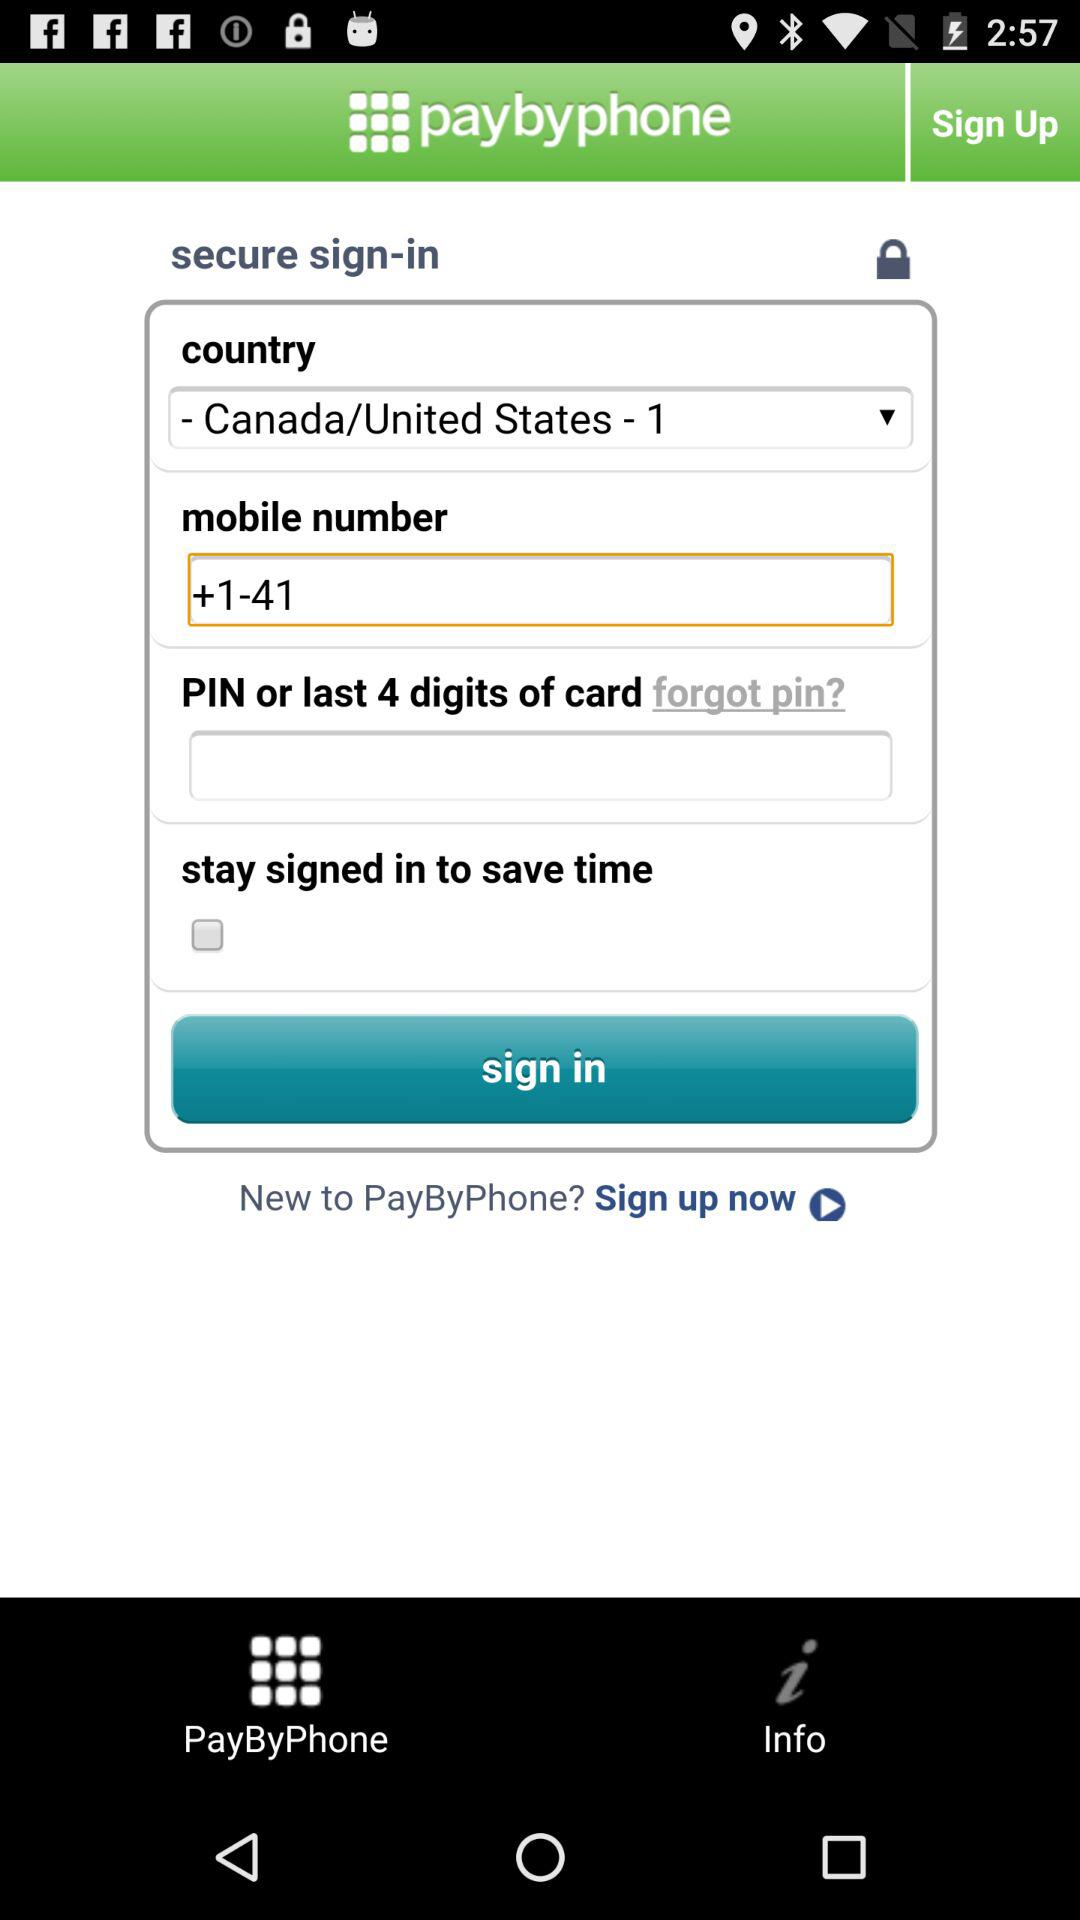How many digits are there in a card pin? There are 4 digits in a card pin. 